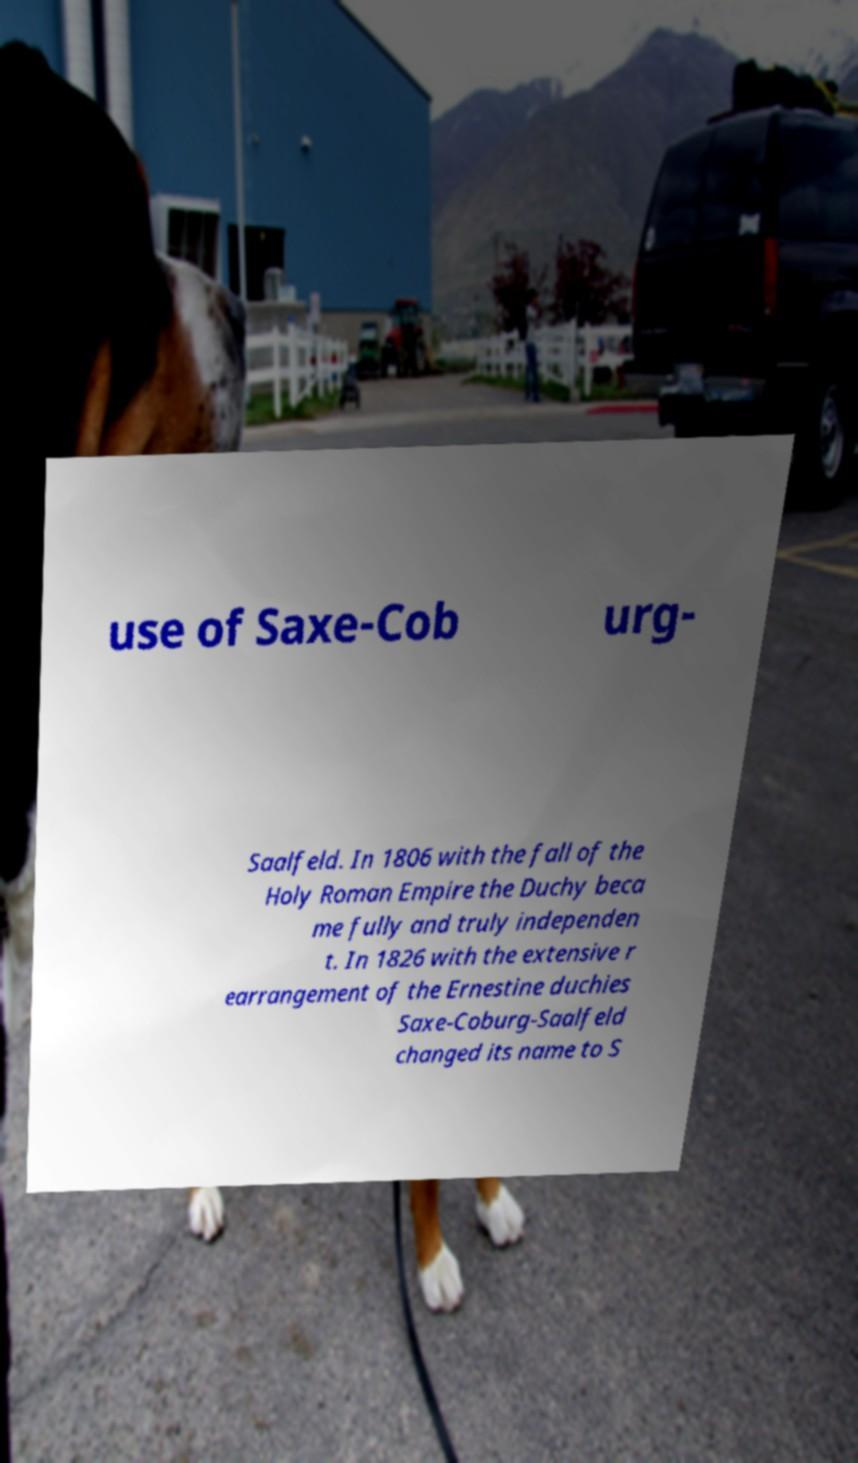Could you assist in decoding the text presented in this image and type it out clearly? use of Saxe-Cob urg- Saalfeld. In 1806 with the fall of the Holy Roman Empire the Duchy beca me fully and truly independen t. In 1826 with the extensive r earrangement of the Ernestine duchies Saxe-Coburg-Saalfeld changed its name to S 